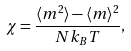Convert formula to latex. <formula><loc_0><loc_0><loc_500><loc_500>\chi = \frac { \langle m ^ { 2 } \rangle - \langle m \rangle ^ { 2 } } { N k _ { B } T } ,</formula> 